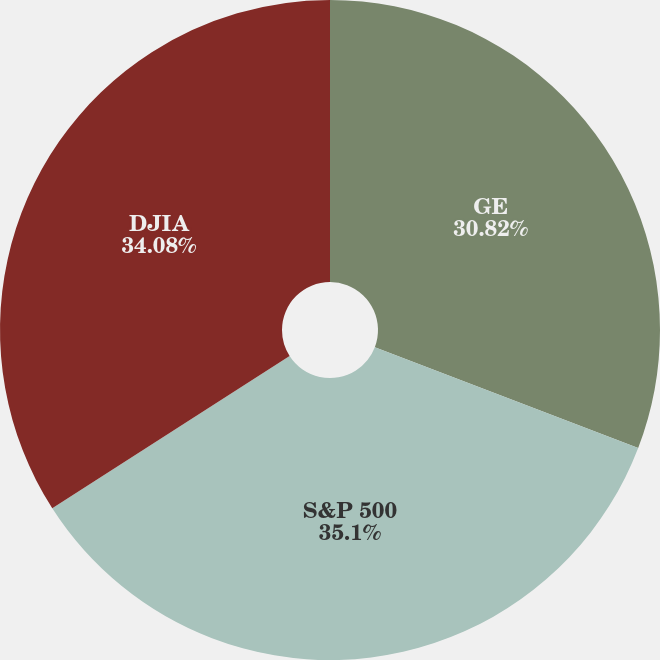Convert chart. <chart><loc_0><loc_0><loc_500><loc_500><pie_chart><fcel>GE<fcel>S&P 500<fcel>DJIA<nl><fcel>30.82%<fcel>35.1%<fcel>34.08%<nl></chart> 